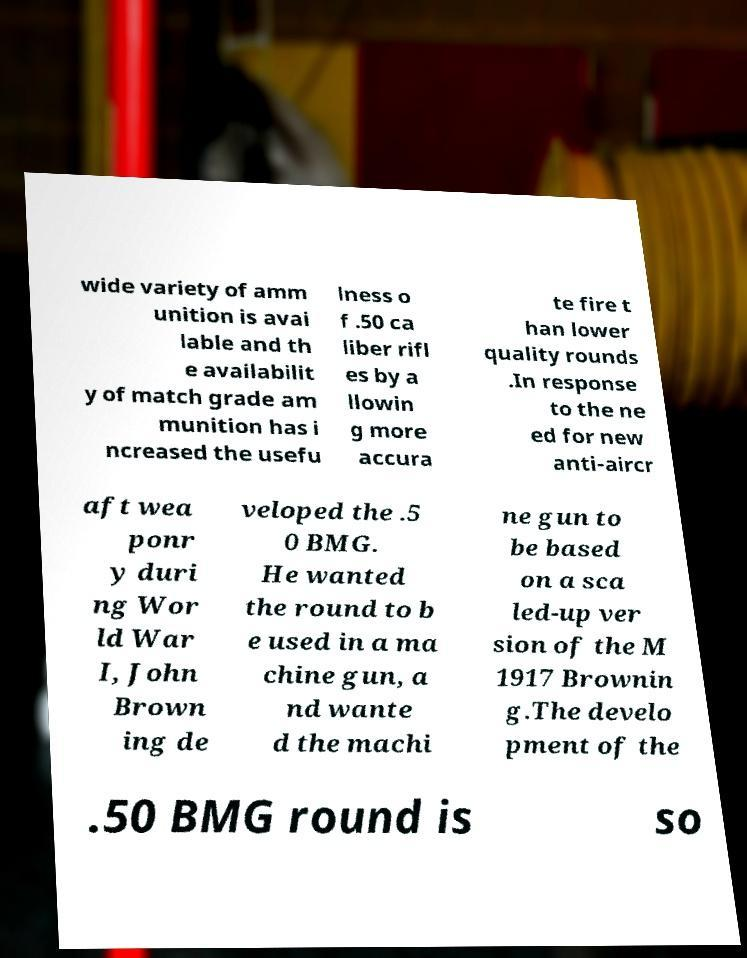Can you accurately transcribe the text from the provided image for me? wide variety of amm unition is avai lable and th e availabilit y of match grade am munition has i ncreased the usefu lness o f .50 ca liber rifl es by a llowin g more accura te fire t han lower quality rounds .In response to the ne ed for new anti-aircr aft wea ponr y duri ng Wor ld War I, John Brown ing de veloped the .5 0 BMG. He wanted the round to b e used in a ma chine gun, a nd wante d the machi ne gun to be based on a sca led-up ver sion of the M 1917 Brownin g.The develo pment of the .50 BMG round is so 